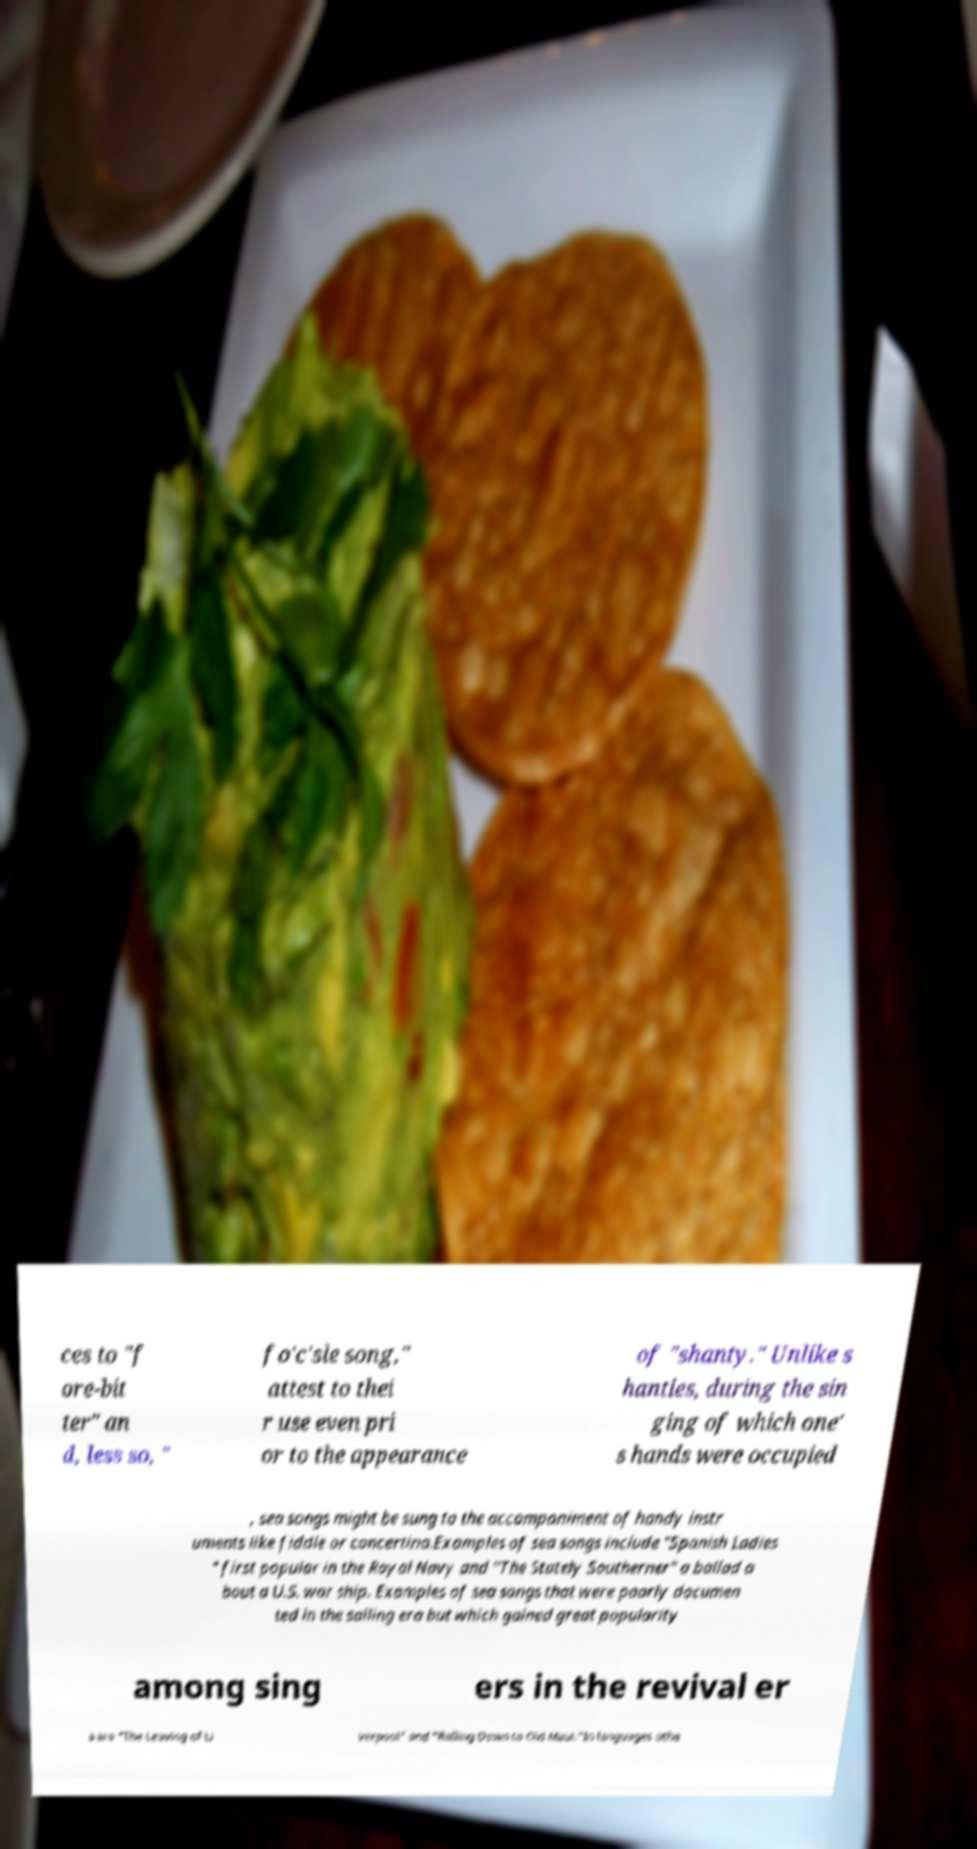For documentation purposes, I need the text within this image transcribed. Could you provide that? ces to "f ore-bit ter" an d, less so, " fo'c'sle song," attest to thei r use even pri or to the appearance of "shanty." Unlike s hanties, during the sin ging of which one' s hands were occupied , sea songs might be sung to the accompaniment of handy instr uments like fiddle or concertina.Examples of sea songs include "Spanish Ladies " first popular in the Royal Navy and "The Stately Southerner" a ballad a bout a U.S. war ship. Examples of sea songs that were poorly documen ted in the sailing era but which gained great popularity among sing ers in the revival er a are "The Leaving of Li verpool" and "Rolling Down to Old Maui."In languages othe 